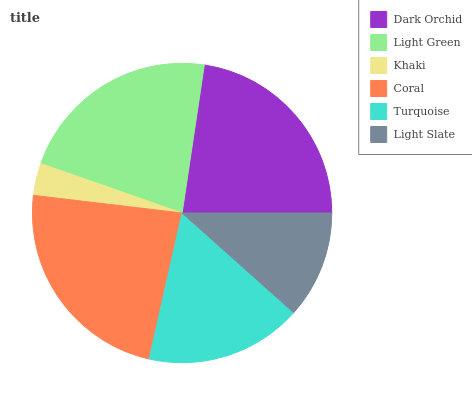Is Khaki the minimum?
Answer yes or no. Yes. Is Coral the maximum?
Answer yes or no. Yes. Is Light Green the minimum?
Answer yes or no. No. Is Light Green the maximum?
Answer yes or no. No. Is Dark Orchid greater than Light Green?
Answer yes or no. Yes. Is Light Green less than Dark Orchid?
Answer yes or no. Yes. Is Light Green greater than Dark Orchid?
Answer yes or no. No. Is Dark Orchid less than Light Green?
Answer yes or no. No. Is Light Green the high median?
Answer yes or no. Yes. Is Turquoise the low median?
Answer yes or no. Yes. Is Coral the high median?
Answer yes or no. No. Is Khaki the low median?
Answer yes or no. No. 